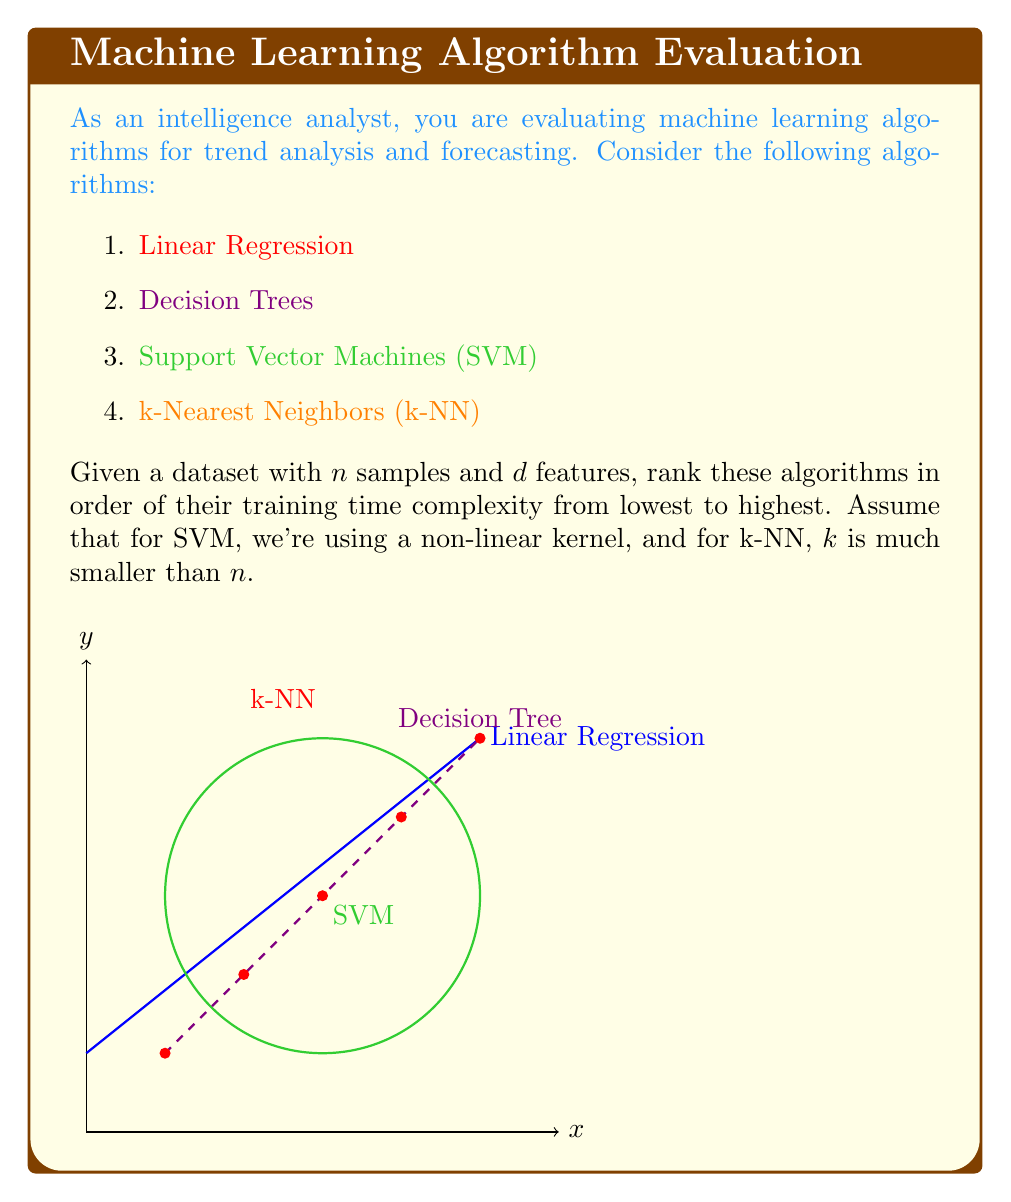Teach me how to tackle this problem. To rank these algorithms, we need to analyze their training time complexities:

1. Linear Regression:
   - Time complexity: $O(nd^2)$
   - This is for ordinary least squares method, which involves matrix operations.

2. Decision Trees:
   - Time complexity: $O(nd \log n)$
   - This assumes an optimized implementation. At each node, we need to sort the data points for each feature.

3. Support Vector Machines (SVM) with non-linear kernel:
   - Time complexity: $O(n^2d)$ to $O(n^3d)$
   - This is because kernel computation is $O(nd)$, and we need to do this for all pairs of points.

4. k-Nearest Neighbors (k-NN):
   - Training time complexity: $O(nd)$
   - k-NN is a lazy learner, so it doesn't do much computation during training. It just stores the training data.

Ranking from lowest to highest training time complexity:

1. k-Nearest Neighbors (k-NN): $O(nd)$
2. Linear Regression: $O(nd^2)$
3. Decision Trees: $O(nd \log n)$
4. Support Vector Machines (SVM): $O(n^2d)$ to $O(n^3d)$

Note that this ranking assumes $n > d$ and $n > \log n$, which is typically the case in real-world datasets.
Answer: k-NN < Linear Regression < Decision Trees < SVM 